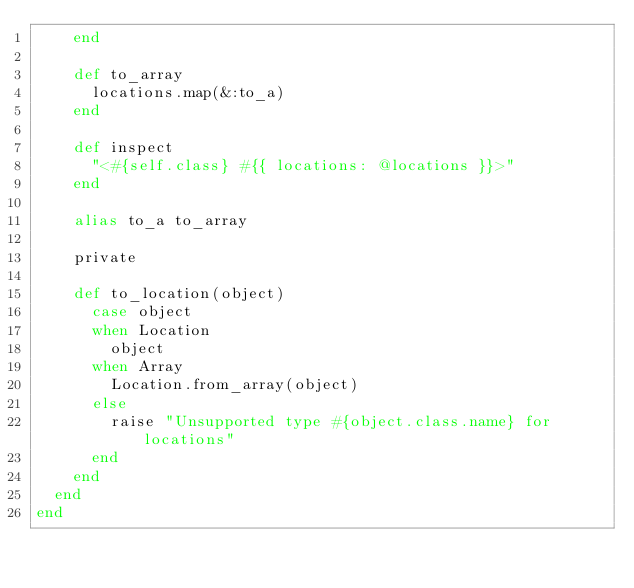<code> <loc_0><loc_0><loc_500><loc_500><_Ruby_>    end

    def to_array
      locations.map(&:to_a)
    end

    def inspect
      "<#{self.class} #{{ locations: @locations }}>"
    end

    alias to_a to_array

    private

    def to_location(object)
      case object
      when Location
        object
      when Array
        Location.from_array(object)
      else
        raise "Unsupported type #{object.class.name} for locations"
      end
    end
  end
end
</code> 